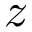Convert formula to latex. <formula><loc_0><loc_0><loc_500><loc_500>z</formula> 